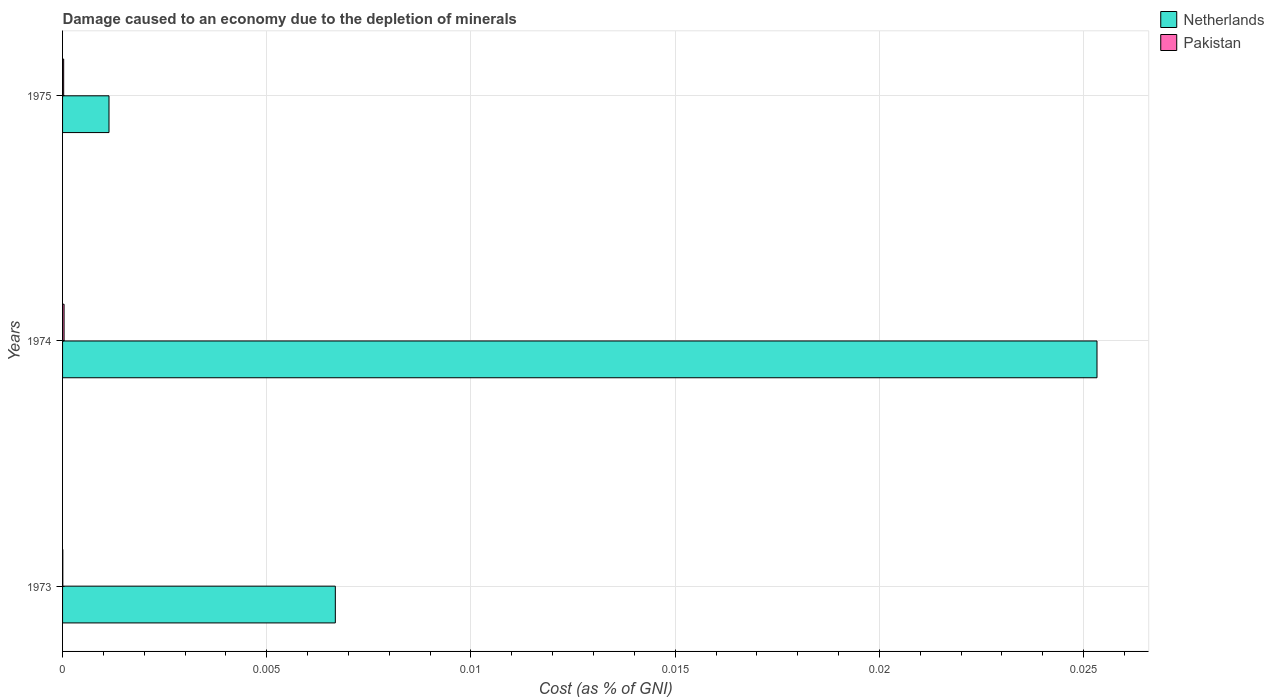How many groups of bars are there?
Make the answer very short. 3. Are the number of bars per tick equal to the number of legend labels?
Provide a succinct answer. Yes. Are the number of bars on each tick of the Y-axis equal?
Provide a succinct answer. Yes. How many bars are there on the 1st tick from the top?
Offer a very short reply. 2. How many bars are there on the 2nd tick from the bottom?
Your answer should be very brief. 2. What is the label of the 2nd group of bars from the top?
Provide a short and direct response. 1974. What is the cost of damage caused due to the depletion of minerals in Netherlands in 1973?
Offer a terse response. 0.01. Across all years, what is the maximum cost of damage caused due to the depletion of minerals in Netherlands?
Make the answer very short. 0.03. Across all years, what is the minimum cost of damage caused due to the depletion of minerals in Pakistan?
Provide a short and direct response. 6.08732957225367e-6. In which year was the cost of damage caused due to the depletion of minerals in Netherlands maximum?
Give a very brief answer. 1974. In which year was the cost of damage caused due to the depletion of minerals in Netherlands minimum?
Provide a short and direct response. 1975. What is the total cost of damage caused due to the depletion of minerals in Pakistan in the graph?
Offer a terse response. 7.014490526958846e-5. What is the difference between the cost of damage caused due to the depletion of minerals in Pakistan in 1973 and that in 1974?
Make the answer very short. -3.0982489585433225e-5. What is the difference between the cost of damage caused due to the depletion of minerals in Netherlands in 1973 and the cost of damage caused due to the depletion of minerals in Pakistan in 1974?
Your response must be concise. 0.01. What is the average cost of damage caused due to the depletion of minerals in Netherlands per year?
Your answer should be very brief. 0.01. In the year 1973, what is the difference between the cost of damage caused due to the depletion of minerals in Netherlands and cost of damage caused due to the depletion of minerals in Pakistan?
Keep it short and to the point. 0.01. What is the ratio of the cost of damage caused due to the depletion of minerals in Pakistan in 1974 to that in 1975?
Offer a very short reply. 1.37. Is the cost of damage caused due to the depletion of minerals in Netherlands in 1973 less than that in 1975?
Your answer should be very brief. No. Is the difference between the cost of damage caused due to the depletion of minerals in Netherlands in 1973 and 1974 greater than the difference between the cost of damage caused due to the depletion of minerals in Pakistan in 1973 and 1974?
Offer a terse response. No. What is the difference between the highest and the second highest cost of damage caused due to the depletion of minerals in Netherlands?
Your answer should be very brief. 0.02. What is the difference between the highest and the lowest cost of damage caused due to the depletion of minerals in Pakistan?
Keep it short and to the point. 3.0982489585433225e-5. In how many years, is the cost of damage caused due to the depletion of minerals in Pakistan greater than the average cost of damage caused due to the depletion of minerals in Pakistan taken over all years?
Provide a short and direct response. 2. Is the sum of the cost of damage caused due to the depletion of minerals in Netherlands in 1973 and 1975 greater than the maximum cost of damage caused due to the depletion of minerals in Pakistan across all years?
Keep it short and to the point. Yes. How many bars are there?
Your answer should be compact. 6. Are all the bars in the graph horizontal?
Ensure brevity in your answer.  Yes. What is the difference between two consecutive major ticks on the X-axis?
Make the answer very short. 0.01. Are the values on the major ticks of X-axis written in scientific E-notation?
Make the answer very short. No. Does the graph contain any zero values?
Make the answer very short. No. Where does the legend appear in the graph?
Your answer should be compact. Top right. How many legend labels are there?
Ensure brevity in your answer.  2. How are the legend labels stacked?
Your answer should be compact. Vertical. What is the title of the graph?
Offer a terse response. Damage caused to an economy due to the depletion of minerals. Does "Marshall Islands" appear as one of the legend labels in the graph?
Provide a short and direct response. No. What is the label or title of the X-axis?
Make the answer very short. Cost (as % of GNI). What is the label or title of the Y-axis?
Provide a short and direct response. Years. What is the Cost (as % of GNI) in Netherlands in 1973?
Make the answer very short. 0.01. What is the Cost (as % of GNI) of Pakistan in 1973?
Your response must be concise. 6.08732957225367e-6. What is the Cost (as % of GNI) of Netherlands in 1974?
Make the answer very short. 0.03. What is the Cost (as % of GNI) of Pakistan in 1974?
Provide a short and direct response. 3.706981915768689e-5. What is the Cost (as % of GNI) in Netherlands in 1975?
Offer a very short reply. 0. What is the Cost (as % of GNI) in Pakistan in 1975?
Your response must be concise. 2.698775653964789e-5. Across all years, what is the maximum Cost (as % of GNI) of Netherlands?
Your response must be concise. 0.03. Across all years, what is the maximum Cost (as % of GNI) in Pakistan?
Your answer should be very brief. 3.706981915768689e-5. Across all years, what is the minimum Cost (as % of GNI) of Netherlands?
Offer a terse response. 0. Across all years, what is the minimum Cost (as % of GNI) in Pakistan?
Provide a succinct answer. 6.08732957225367e-6. What is the total Cost (as % of GNI) of Netherlands in the graph?
Provide a short and direct response. 0.03. What is the total Cost (as % of GNI) of Pakistan in the graph?
Offer a terse response. 0. What is the difference between the Cost (as % of GNI) in Netherlands in 1973 and that in 1974?
Provide a succinct answer. -0.02. What is the difference between the Cost (as % of GNI) in Netherlands in 1973 and that in 1975?
Offer a very short reply. 0.01. What is the difference between the Cost (as % of GNI) in Netherlands in 1974 and that in 1975?
Ensure brevity in your answer.  0.02. What is the difference between the Cost (as % of GNI) of Netherlands in 1973 and the Cost (as % of GNI) of Pakistan in 1974?
Ensure brevity in your answer.  0.01. What is the difference between the Cost (as % of GNI) in Netherlands in 1973 and the Cost (as % of GNI) in Pakistan in 1975?
Offer a terse response. 0.01. What is the difference between the Cost (as % of GNI) of Netherlands in 1974 and the Cost (as % of GNI) of Pakistan in 1975?
Provide a short and direct response. 0.03. What is the average Cost (as % of GNI) in Netherlands per year?
Offer a very short reply. 0.01. What is the average Cost (as % of GNI) in Pakistan per year?
Give a very brief answer. 0. In the year 1973, what is the difference between the Cost (as % of GNI) in Netherlands and Cost (as % of GNI) in Pakistan?
Give a very brief answer. 0.01. In the year 1974, what is the difference between the Cost (as % of GNI) of Netherlands and Cost (as % of GNI) of Pakistan?
Provide a short and direct response. 0.03. In the year 1975, what is the difference between the Cost (as % of GNI) in Netherlands and Cost (as % of GNI) in Pakistan?
Your response must be concise. 0. What is the ratio of the Cost (as % of GNI) of Netherlands in 1973 to that in 1974?
Provide a short and direct response. 0.26. What is the ratio of the Cost (as % of GNI) of Pakistan in 1973 to that in 1974?
Your response must be concise. 0.16. What is the ratio of the Cost (as % of GNI) in Netherlands in 1973 to that in 1975?
Provide a succinct answer. 5.87. What is the ratio of the Cost (as % of GNI) in Pakistan in 1973 to that in 1975?
Your answer should be very brief. 0.23. What is the ratio of the Cost (as % of GNI) in Netherlands in 1974 to that in 1975?
Your answer should be compact. 22.27. What is the ratio of the Cost (as % of GNI) in Pakistan in 1974 to that in 1975?
Keep it short and to the point. 1.37. What is the difference between the highest and the second highest Cost (as % of GNI) of Netherlands?
Provide a succinct answer. 0.02. What is the difference between the highest and the lowest Cost (as % of GNI) in Netherlands?
Ensure brevity in your answer.  0.02. 